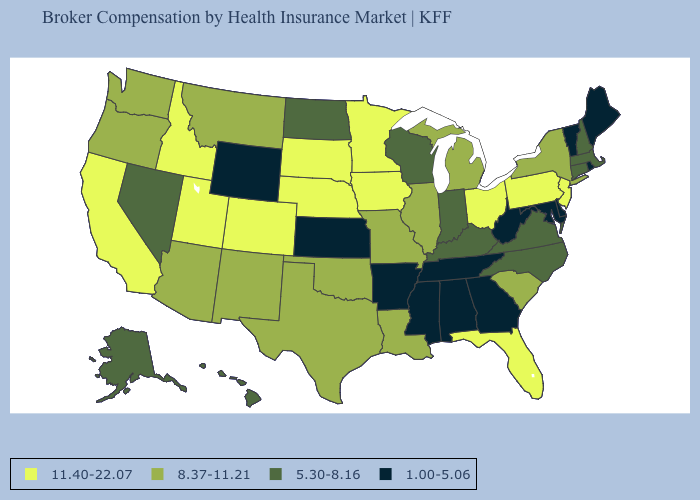What is the value of Louisiana?
Give a very brief answer. 8.37-11.21. Which states hav the highest value in the West?
Short answer required. California, Colorado, Idaho, Utah. What is the value of New Jersey?
Be succinct. 11.40-22.07. Name the states that have a value in the range 8.37-11.21?
Quick response, please. Arizona, Illinois, Louisiana, Michigan, Missouri, Montana, New Mexico, New York, Oklahoma, Oregon, South Carolina, Texas, Washington. Does Pennsylvania have the highest value in the USA?
Keep it brief. Yes. Name the states that have a value in the range 1.00-5.06?
Give a very brief answer. Alabama, Arkansas, Delaware, Georgia, Kansas, Maine, Maryland, Mississippi, Rhode Island, Tennessee, Vermont, West Virginia, Wyoming. What is the highest value in the USA?
Give a very brief answer. 11.40-22.07. What is the value of Idaho?
Write a very short answer. 11.40-22.07. What is the lowest value in the Northeast?
Give a very brief answer. 1.00-5.06. Name the states that have a value in the range 1.00-5.06?
Short answer required. Alabama, Arkansas, Delaware, Georgia, Kansas, Maine, Maryland, Mississippi, Rhode Island, Tennessee, Vermont, West Virginia, Wyoming. What is the lowest value in the USA?
Keep it brief. 1.00-5.06. Name the states that have a value in the range 1.00-5.06?
Give a very brief answer. Alabama, Arkansas, Delaware, Georgia, Kansas, Maine, Maryland, Mississippi, Rhode Island, Tennessee, Vermont, West Virginia, Wyoming. What is the lowest value in the USA?
Keep it brief. 1.00-5.06. Which states have the lowest value in the USA?
Quick response, please. Alabama, Arkansas, Delaware, Georgia, Kansas, Maine, Maryland, Mississippi, Rhode Island, Tennessee, Vermont, West Virginia, Wyoming. What is the highest value in states that border Arkansas?
Write a very short answer. 8.37-11.21. 